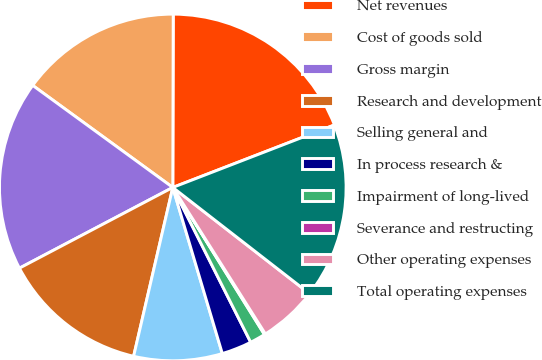Convert chart. <chart><loc_0><loc_0><loc_500><loc_500><pie_chart><fcel>Net revenues<fcel>Cost of goods sold<fcel>Gross margin<fcel>Research and development<fcel>Selling general and<fcel>In process research &<fcel>Impairment of long-lived<fcel>Severance and restructing<fcel>Other operating expenses<fcel>Total operating expenses<nl><fcel>19.09%<fcel>15.02%<fcel>17.73%<fcel>13.66%<fcel>8.24%<fcel>2.81%<fcel>1.45%<fcel>0.1%<fcel>5.52%<fcel>16.38%<nl></chart> 